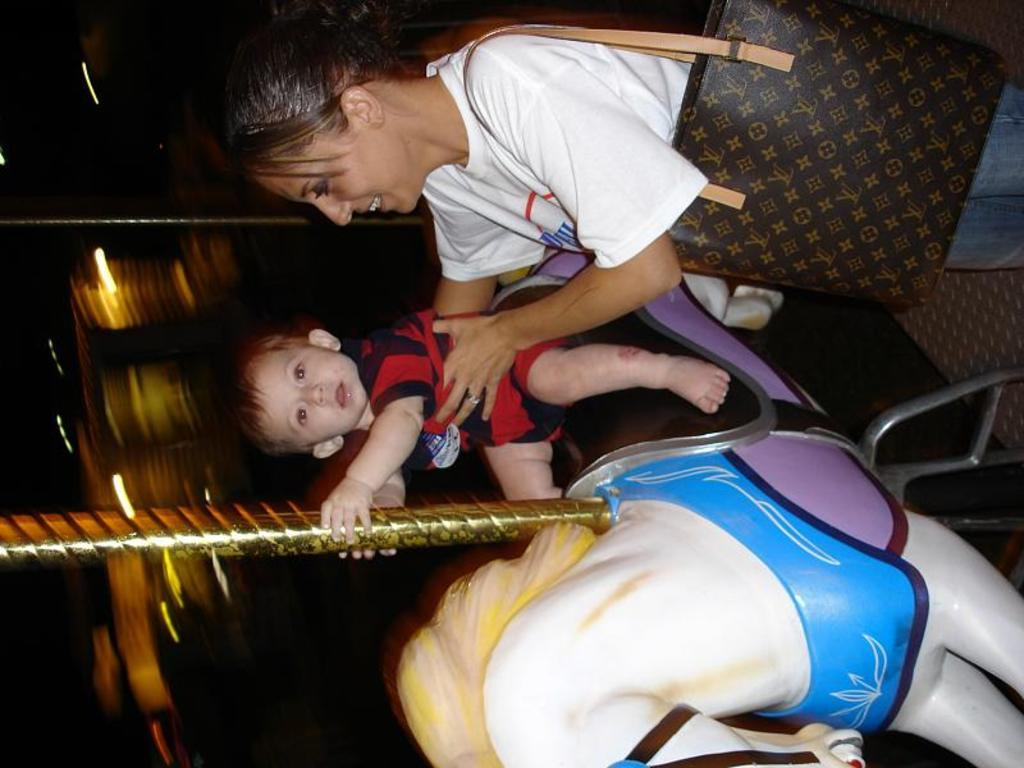Who is present in the image? There is a woman and a kid in the image. Can you describe the relationship between the woman and the kid? The relationship between the woman and the kid is not specified in the image. What is the woman doing in the image? The actions of the woman are not specified in the image. What is the kid doing in the image? The actions of the kid are not specified in the image. What color is the carpenter's apron in the image? There is no carpenter or apron present in the image. How does the woman rub the color onto the kid's face in the image? There is no rubbing or coloring of the kid's face depicted in the image. 